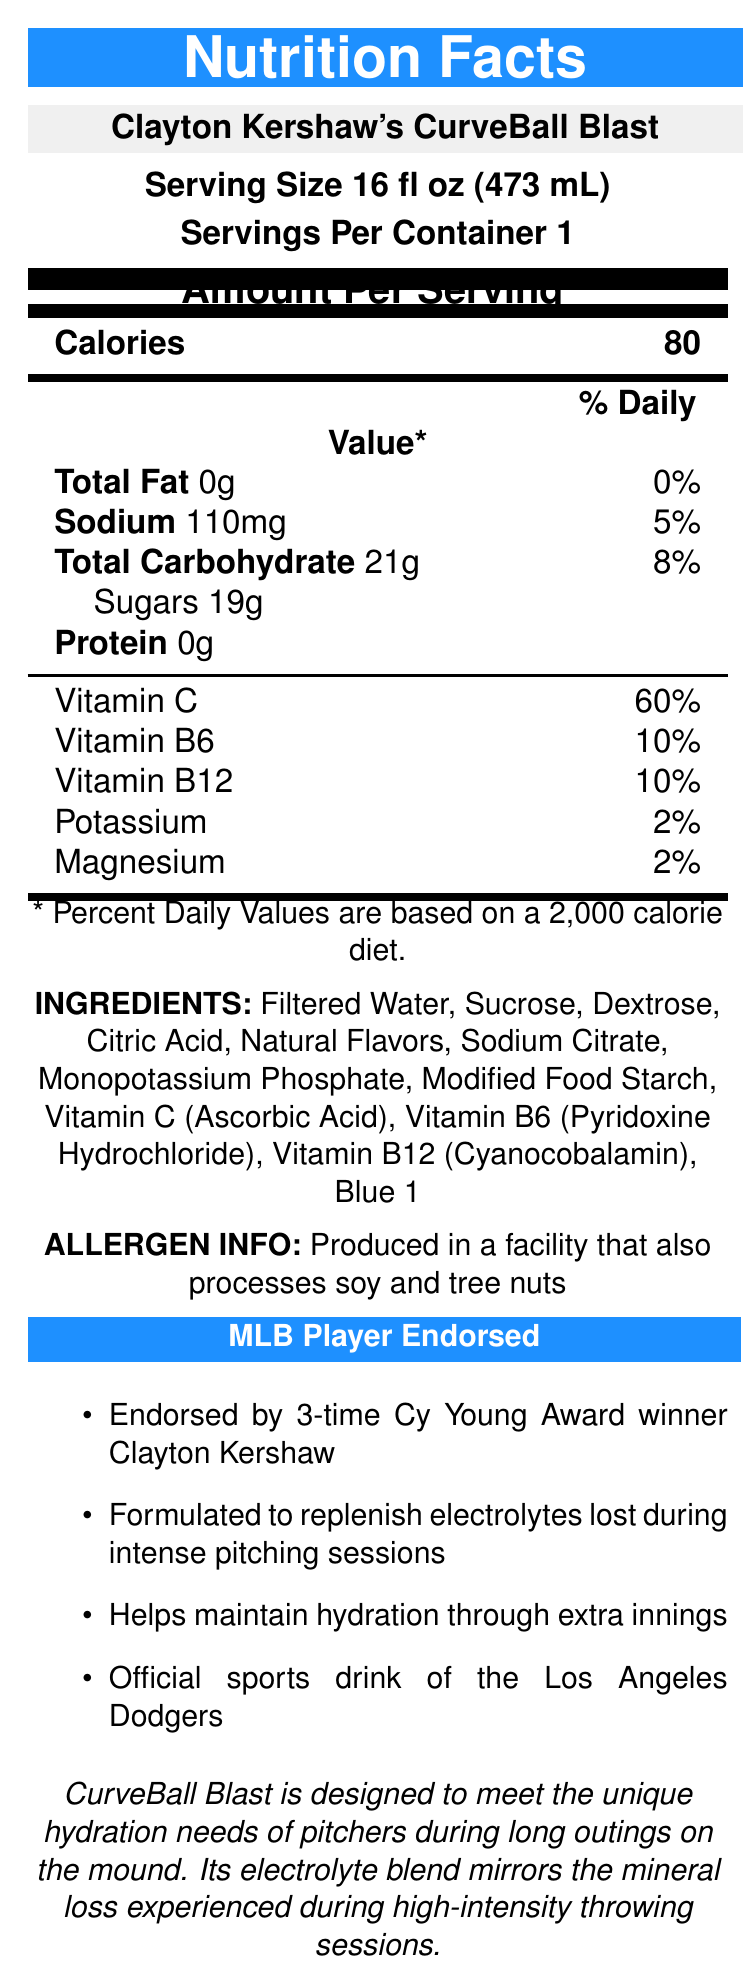what is the product name? The product name is listed prominently at the beginning of the document and under the Nutrition Facts header.
Answer: Clayton Kershaw's CurveBall Blast how many calories are there per serving? The calories per serving are displayed in bold within the nutrition facts section.
Answer: 80 what is the serving size? The serving size is specified under the heading 'Serving Size' near the top of the document.
Answer: 16 fl oz (473 mL) how much sugar is in one serving? The amount of sugar is detailed in the total carbohydrate section of the nutrition facts.
Answer: 19g what are the main ingredients? The ingredients are listed under the Ingredients section.
Answer: Filtered Water, Sucrose, Dextrose, Citric Acid, Natural Flavors, Sodium Citrate, Monopotassium Phosphate, Modified Food Starch, Vitamin C (Ascorbic Acid), Vitamin B6 (Pyridoxine Hydrochloride), Vitamin B12 (Cyanocobalamin), Blue 1 does this product contain any protein? The document lists 0g of protein under the nutrition facts.
Answer: No who endorses this sports drink? A. Mike Trout B. Clayton Kershaw C. Mookie Betts D. Max Scherzer The document mentions that the sports drink is endorsed by 3-time Cy Young Award winner Clayton Kershaw multiple times.
Answer: B. Clayton Kershaw what is the official sports drink of the Los Angeles Dodgers? A. Powerade B. Gatorade C. BodyArmor D. Clayton Kershaw's CurveBall Blast The document states that Clayton Kershaw's CurveBall Blast is the official sports drink of the Los Angeles Dodgers.
Answer: D. Clayton Kershaw's CurveBall Blast is the product produced in a facility that processes tree nuts? The allergen information specifies that it is produced in a facility that also processes soy and tree nuts.
Answer: Yes please summarize the main idea of the document. The document includes various sections such as the product name, serving size, servings per container, calories, detailed nutritional information, ingredients, allergen info, and several marketing claims related to its endorsement and purpose.
Answer: The document is a detailed nutrition facts label for "Clayton Kershaw's CurveBall Blast," a sports drink endorsed by the MLB pitcher Clayton Kershaw. It provides nutritional information, ingredients, allergen info, and marketing claims, describing it as a product designed to replenish electrolytes and maintain hydration specifically for baseball pitchers during intense games and long outings. what is the daily value percentage of Vitamin C in one serving? The document lists the percentage daily value of Vitamin C as 60% under the vitamins and minerals section of the nutrition facts.
Answer: 60% how many servings are in a container? The serving per container is listed directly under the serving size near the top of the document.
Answer: 1 is Vitamin D mentioned in the document? The document does not list Vitamin D; it only lists the vitamins C, B6, and B12.
Answer: No what benefits does the sports drink claim to provide? The document outlines these benefits in the marketing claims section.
Answer: Replenishes electrolytes lost during intense pitching sessions, helps maintain hydration through extra innings, and is the official sports drink of the Los Angeles Dodgers. what kind of vitamin does the product NOT contain? The document lists specific vitamins in the product, but it doesn’t state which vitamins are not included explicitly.
Answer: Cannot be determined how much sodium does one serving contain? The amount of sodium per serving is specified in the nutrition facts.
Answer: 110mg 